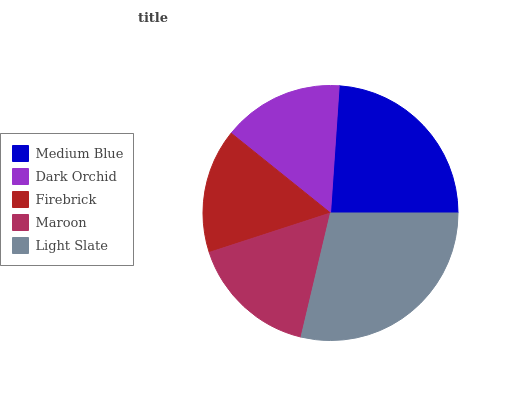Is Dark Orchid the minimum?
Answer yes or no. Yes. Is Light Slate the maximum?
Answer yes or no. Yes. Is Firebrick the minimum?
Answer yes or no. No. Is Firebrick the maximum?
Answer yes or no. No. Is Firebrick greater than Dark Orchid?
Answer yes or no. Yes. Is Dark Orchid less than Firebrick?
Answer yes or no. Yes. Is Dark Orchid greater than Firebrick?
Answer yes or no. No. Is Firebrick less than Dark Orchid?
Answer yes or no. No. Is Maroon the high median?
Answer yes or no. Yes. Is Maroon the low median?
Answer yes or no. Yes. Is Medium Blue the high median?
Answer yes or no. No. Is Light Slate the low median?
Answer yes or no. No. 